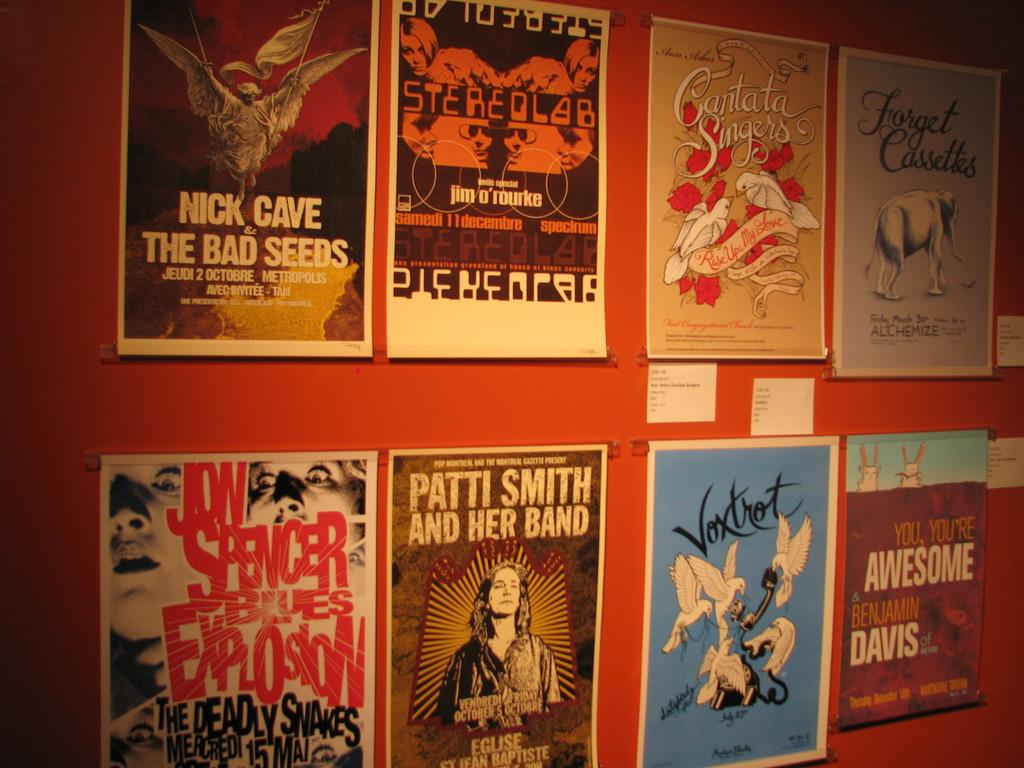<image>
Write a terse but informative summary of the picture. Several posters for different bands such as Patti Smith are displayed. 